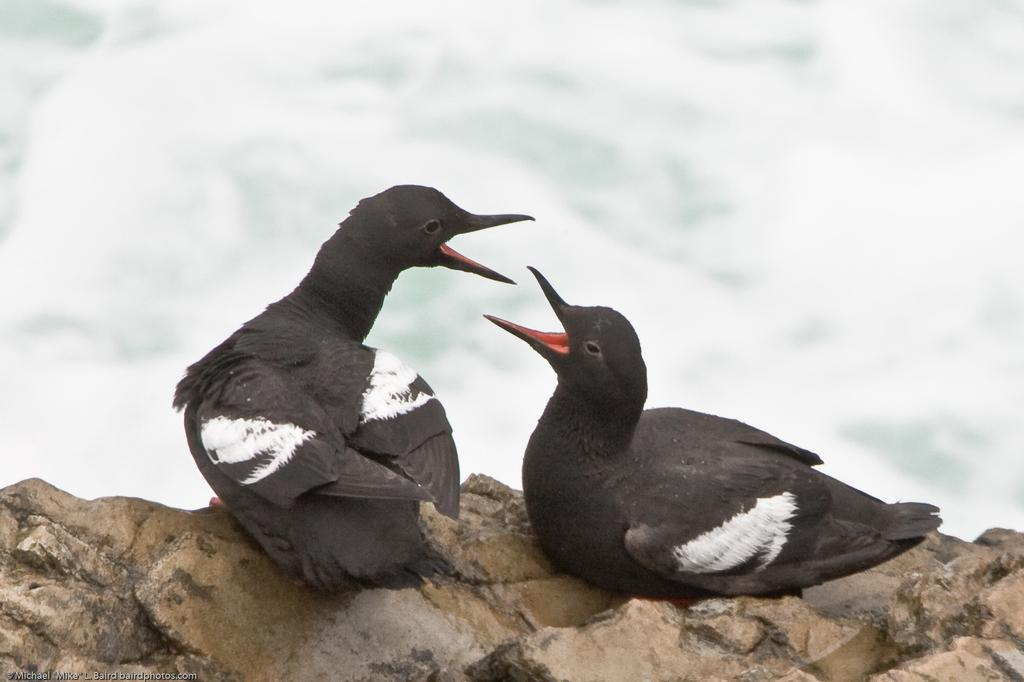How many birds are in the image? There are two birds in the image. Where are the birds located? The birds are on a rock. What can be seen in the background of the image? There is water visible in the background of the image. What type of seat can be seen in the image? There is no seat present in the image; it features two birds on a rock with water visible in the background. 